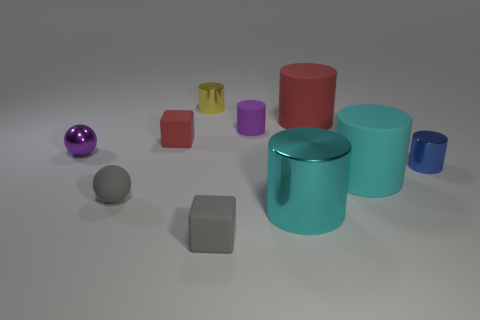Subtract all big cyan shiny cylinders. How many cylinders are left? 5 Subtract all purple balls. How many balls are left? 1 Subtract 1 cubes. How many cubes are left? 1 Add 3 tiny gray blocks. How many tiny gray blocks are left? 4 Add 5 small red matte things. How many small red matte things exist? 6 Subtract 0 cyan balls. How many objects are left? 10 Subtract all balls. How many objects are left? 8 Subtract all brown spheres. Subtract all cyan cylinders. How many spheres are left? 2 Subtract all yellow cylinders. How many gray spheres are left? 1 Subtract all metallic spheres. Subtract all small rubber blocks. How many objects are left? 7 